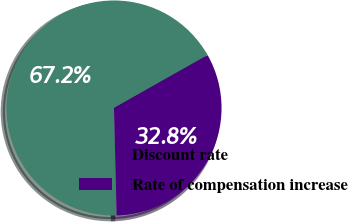Convert chart to OTSL. <chart><loc_0><loc_0><loc_500><loc_500><pie_chart><fcel>Discount rate<fcel>Rate of compensation increase<nl><fcel>67.21%<fcel>32.79%<nl></chart> 